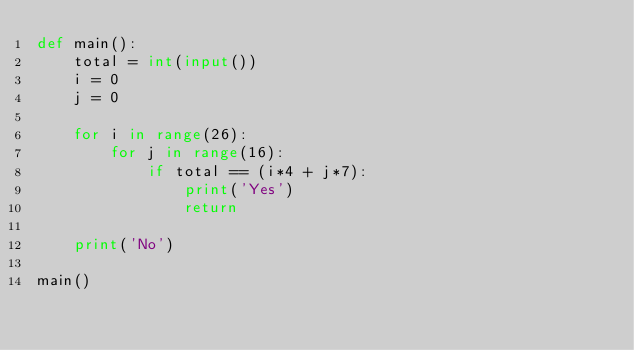<code> <loc_0><loc_0><loc_500><loc_500><_Python_>def main():
    total = int(input())
    i = 0
    j = 0

    for i in range(26):
        for j in range(16):
            if total == (i*4 + j*7):
                print('Yes')
                return

    print('No')

main()
</code> 